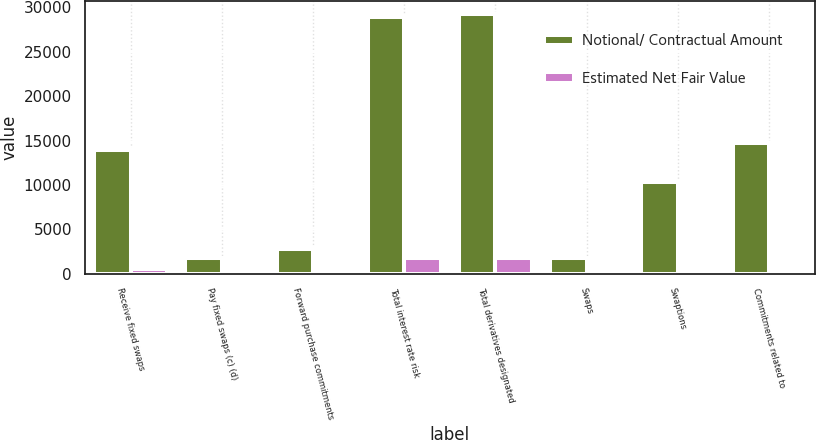Convert chart. <chart><loc_0><loc_0><loc_500><loc_500><stacked_bar_chart><ecel><fcel>Receive fixed swaps<fcel>Pay fixed swaps (c) (d)<fcel>Forward purchase commitments<fcel>Total interest rate risk<fcel>Total derivatives designated<fcel>Swaps<fcel>Swaptions<fcel>Commitments related to<nl><fcel>Notional/ Contractual Amount<fcel>13902<fcel>1797<fcel>2733<fcel>28908<fcel>29234<fcel>1772<fcel>10312<fcel>14773<nl><fcel>Estimated Net Fair Value<fcel>529<fcel>116<fcel>43<fcel>1772<fcel>1772<fcel>454<fcel>49<fcel>59<nl></chart> 